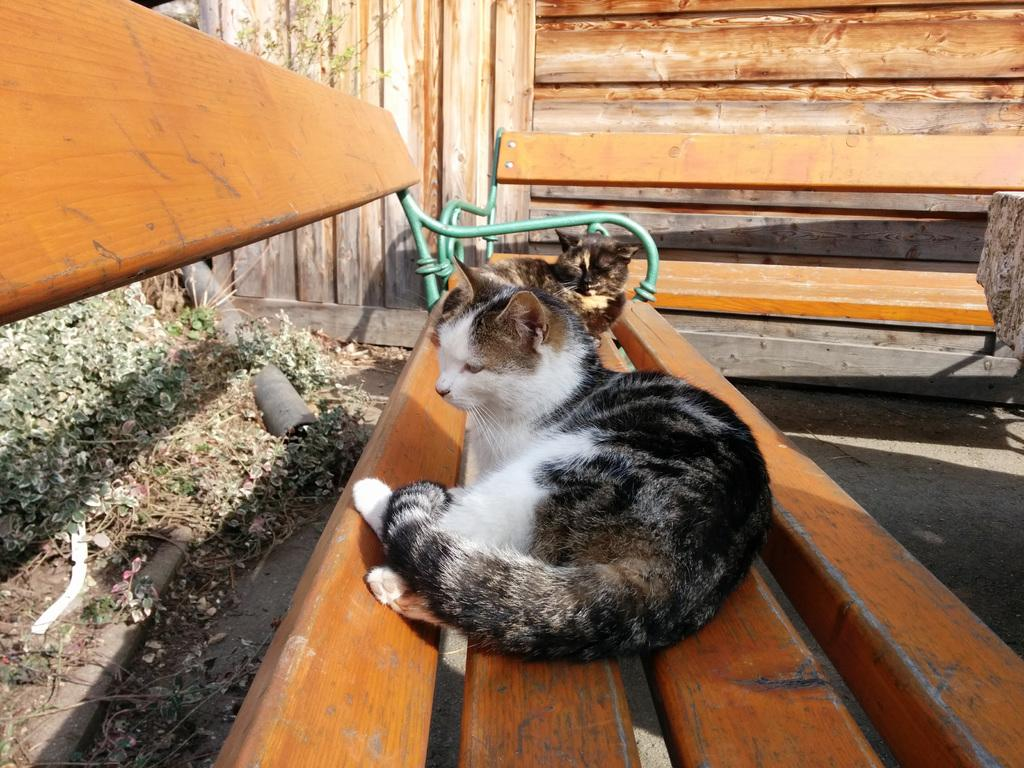What type of animal is in the image? There is a cat in the image. Where is the cat located in the image? The cat is laying on a bench. What type of key is the cat using to unlock the nation's prose in the image? There is no key or reference to a nation's prose present in the image; it features a cat laying on a bench. 